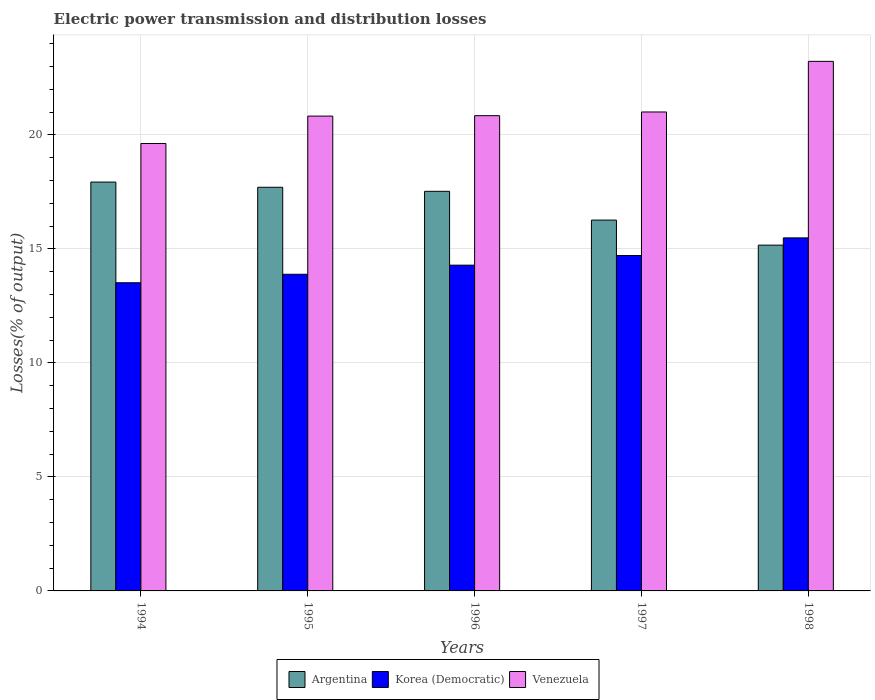How many groups of bars are there?
Keep it short and to the point. 5. Are the number of bars on each tick of the X-axis equal?
Keep it short and to the point. Yes. How many bars are there on the 4th tick from the left?
Keep it short and to the point. 3. What is the label of the 4th group of bars from the left?
Provide a succinct answer. 1997. In how many cases, is the number of bars for a given year not equal to the number of legend labels?
Give a very brief answer. 0. What is the electric power transmission and distribution losses in Korea (Democratic) in 1996?
Keep it short and to the point. 14.29. Across all years, what is the maximum electric power transmission and distribution losses in Venezuela?
Your answer should be compact. 23.22. Across all years, what is the minimum electric power transmission and distribution losses in Venezuela?
Provide a succinct answer. 19.62. In which year was the electric power transmission and distribution losses in Korea (Democratic) minimum?
Offer a very short reply. 1994. What is the total electric power transmission and distribution losses in Venezuela in the graph?
Your answer should be very brief. 105.52. What is the difference between the electric power transmission and distribution losses in Korea (Democratic) in 1994 and that in 1995?
Provide a succinct answer. -0.37. What is the difference between the electric power transmission and distribution losses in Korea (Democratic) in 1998 and the electric power transmission and distribution losses in Argentina in 1995?
Keep it short and to the point. -2.22. What is the average electric power transmission and distribution losses in Venezuela per year?
Your answer should be compact. 21.1. In the year 1994, what is the difference between the electric power transmission and distribution losses in Argentina and electric power transmission and distribution losses in Korea (Democratic)?
Offer a very short reply. 4.42. In how many years, is the electric power transmission and distribution losses in Venezuela greater than 1 %?
Your answer should be very brief. 5. What is the ratio of the electric power transmission and distribution losses in Korea (Democratic) in 1996 to that in 1997?
Your answer should be compact. 0.97. Is the electric power transmission and distribution losses in Korea (Democratic) in 1996 less than that in 1998?
Provide a short and direct response. Yes. What is the difference between the highest and the second highest electric power transmission and distribution losses in Argentina?
Your answer should be very brief. 0.23. What is the difference between the highest and the lowest electric power transmission and distribution losses in Korea (Democratic)?
Ensure brevity in your answer.  1.97. In how many years, is the electric power transmission and distribution losses in Korea (Democratic) greater than the average electric power transmission and distribution losses in Korea (Democratic) taken over all years?
Your response must be concise. 2. What does the 2nd bar from the left in 1994 represents?
Provide a short and direct response. Korea (Democratic). What does the 1st bar from the right in 1994 represents?
Ensure brevity in your answer.  Venezuela. Is it the case that in every year, the sum of the electric power transmission and distribution losses in Argentina and electric power transmission and distribution losses in Venezuela is greater than the electric power transmission and distribution losses in Korea (Democratic)?
Provide a short and direct response. Yes. How many bars are there?
Offer a very short reply. 15. Are all the bars in the graph horizontal?
Provide a short and direct response. No. Are the values on the major ticks of Y-axis written in scientific E-notation?
Your answer should be very brief. No. Where does the legend appear in the graph?
Your response must be concise. Bottom center. How many legend labels are there?
Give a very brief answer. 3. What is the title of the graph?
Offer a terse response. Electric power transmission and distribution losses. Does "Algeria" appear as one of the legend labels in the graph?
Ensure brevity in your answer.  No. What is the label or title of the Y-axis?
Give a very brief answer. Losses(% of output). What is the Losses(% of output) in Argentina in 1994?
Keep it short and to the point. 17.93. What is the Losses(% of output) of Korea (Democratic) in 1994?
Ensure brevity in your answer.  13.52. What is the Losses(% of output) in Venezuela in 1994?
Offer a terse response. 19.62. What is the Losses(% of output) of Argentina in 1995?
Provide a succinct answer. 17.7. What is the Losses(% of output) in Korea (Democratic) in 1995?
Make the answer very short. 13.89. What is the Losses(% of output) of Venezuela in 1995?
Your answer should be compact. 20.82. What is the Losses(% of output) of Argentina in 1996?
Provide a succinct answer. 17.52. What is the Losses(% of output) of Korea (Democratic) in 1996?
Your answer should be compact. 14.29. What is the Losses(% of output) in Venezuela in 1996?
Offer a very short reply. 20.84. What is the Losses(% of output) of Argentina in 1997?
Your response must be concise. 16.26. What is the Losses(% of output) in Korea (Democratic) in 1997?
Your answer should be compact. 14.71. What is the Losses(% of output) of Venezuela in 1997?
Give a very brief answer. 21. What is the Losses(% of output) of Argentina in 1998?
Make the answer very short. 15.16. What is the Losses(% of output) of Korea (Democratic) in 1998?
Your answer should be compact. 15.48. What is the Losses(% of output) in Venezuela in 1998?
Your answer should be very brief. 23.22. Across all years, what is the maximum Losses(% of output) of Argentina?
Make the answer very short. 17.93. Across all years, what is the maximum Losses(% of output) of Korea (Democratic)?
Provide a succinct answer. 15.48. Across all years, what is the maximum Losses(% of output) in Venezuela?
Offer a terse response. 23.22. Across all years, what is the minimum Losses(% of output) in Argentina?
Offer a terse response. 15.16. Across all years, what is the minimum Losses(% of output) in Korea (Democratic)?
Offer a terse response. 13.52. Across all years, what is the minimum Losses(% of output) of Venezuela?
Keep it short and to the point. 19.62. What is the total Losses(% of output) in Argentina in the graph?
Offer a terse response. 84.58. What is the total Losses(% of output) in Korea (Democratic) in the graph?
Provide a short and direct response. 71.88. What is the total Losses(% of output) in Venezuela in the graph?
Your response must be concise. 105.52. What is the difference between the Losses(% of output) in Argentina in 1994 and that in 1995?
Give a very brief answer. 0.23. What is the difference between the Losses(% of output) in Korea (Democratic) in 1994 and that in 1995?
Make the answer very short. -0.37. What is the difference between the Losses(% of output) of Venezuela in 1994 and that in 1995?
Your answer should be compact. -1.2. What is the difference between the Losses(% of output) in Argentina in 1994 and that in 1996?
Your response must be concise. 0.41. What is the difference between the Losses(% of output) in Korea (Democratic) in 1994 and that in 1996?
Your answer should be very brief. -0.77. What is the difference between the Losses(% of output) of Venezuela in 1994 and that in 1996?
Your answer should be compact. -1.22. What is the difference between the Losses(% of output) in Argentina in 1994 and that in 1997?
Your answer should be very brief. 1.67. What is the difference between the Losses(% of output) in Korea (Democratic) in 1994 and that in 1997?
Ensure brevity in your answer.  -1.19. What is the difference between the Losses(% of output) of Venezuela in 1994 and that in 1997?
Provide a succinct answer. -1.38. What is the difference between the Losses(% of output) of Argentina in 1994 and that in 1998?
Provide a succinct answer. 2.77. What is the difference between the Losses(% of output) of Korea (Democratic) in 1994 and that in 1998?
Provide a succinct answer. -1.97. What is the difference between the Losses(% of output) in Venezuela in 1994 and that in 1998?
Keep it short and to the point. -3.6. What is the difference between the Losses(% of output) of Argentina in 1995 and that in 1996?
Keep it short and to the point. 0.18. What is the difference between the Losses(% of output) in Korea (Democratic) in 1995 and that in 1996?
Make the answer very short. -0.4. What is the difference between the Losses(% of output) of Venezuela in 1995 and that in 1996?
Provide a short and direct response. -0.02. What is the difference between the Losses(% of output) in Argentina in 1995 and that in 1997?
Your answer should be compact. 1.44. What is the difference between the Losses(% of output) in Korea (Democratic) in 1995 and that in 1997?
Your answer should be compact. -0.82. What is the difference between the Losses(% of output) in Venezuela in 1995 and that in 1997?
Offer a terse response. -0.18. What is the difference between the Losses(% of output) of Argentina in 1995 and that in 1998?
Provide a succinct answer. 2.54. What is the difference between the Losses(% of output) in Korea (Democratic) in 1995 and that in 1998?
Your answer should be compact. -1.6. What is the difference between the Losses(% of output) in Venezuela in 1995 and that in 1998?
Provide a short and direct response. -2.4. What is the difference between the Losses(% of output) in Argentina in 1996 and that in 1997?
Offer a very short reply. 1.26. What is the difference between the Losses(% of output) of Korea (Democratic) in 1996 and that in 1997?
Keep it short and to the point. -0.42. What is the difference between the Losses(% of output) of Venezuela in 1996 and that in 1997?
Your answer should be very brief. -0.16. What is the difference between the Losses(% of output) of Argentina in 1996 and that in 1998?
Offer a terse response. 2.36. What is the difference between the Losses(% of output) of Korea (Democratic) in 1996 and that in 1998?
Offer a terse response. -1.2. What is the difference between the Losses(% of output) in Venezuela in 1996 and that in 1998?
Ensure brevity in your answer.  -2.38. What is the difference between the Losses(% of output) in Argentina in 1997 and that in 1998?
Make the answer very short. 1.1. What is the difference between the Losses(% of output) in Korea (Democratic) in 1997 and that in 1998?
Make the answer very short. -0.77. What is the difference between the Losses(% of output) in Venezuela in 1997 and that in 1998?
Offer a very short reply. -2.22. What is the difference between the Losses(% of output) of Argentina in 1994 and the Losses(% of output) of Korea (Democratic) in 1995?
Your answer should be very brief. 4.04. What is the difference between the Losses(% of output) of Argentina in 1994 and the Losses(% of output) of Venezuela in 1995?
Ensure brevity in your answer.  -2.89. What is the difference between the Losses(% of output) of Korea (Democratic) in 1994 and the Losses(% of output) of Venezuela in 1995?
Provide a succinct answer. -7.31. What is the difference between the Losses(% of output) of Argentina in 1994 and the Losses(% of output) of Korea (Democratic) in 1996?
Offer a terse response. 3.64. What is the difference between the Losses(% of output) of Argentina in 1994 and the Losses(% of output) of Venezuela in 1996?
Your answer should be compact. -2.91. What is the difference between the Losses(% of output) of Korea (Democratic) in 1994 and the Losses(% of output) of Venezuela in 1996?
Provide a succinct answer. -7.33. What is the difference between the Losses(% of output) of Argentina in 1994 and the Losses(% of output) of Korea (Democratic) in 1997?
Offer a very short reply. 3.22. What is the difference between the Losses(% of output) of Argentina in 1994 and the Losses(% of output) of Venezuela in 1997?
Provide a short and direct response. -3.07. What is the difference between the Losses(% of output) in Korea (Democratic) in 1994 and the Losses(% of output) in Venezuela in 1997?
Provide a short and direct response. -7.49. What is the difference between the Losses(% of output) of Argentina in 1994 and the Losses(% of output) of Korea (Democratic) in 1998?
Make the answer very short. 2.45. What is the difference between the Losses(% of output) in Argentina in 1994 and the Losses(% of output) in Venezuela in 1998?
Offer a very short reply. -5.29. What is the difference between the Losses(% of output) in Korea (Democratic) in 1994 and the Losses(% of output) in Venezuela in 1998?
Provide a succinct answer. -9.71. What is the difference between the Losses(% of output) in Argentina in 1995 and the Losses(% of output) in Korea (Democratic) in 1996?
Provide a succinct answer. 3.42. What is the difference between the Losses(% of output) of Argentina in 1995 and the Losses(% of output) of Venezuela in 1996?
Make the answer very short. -3.14. What is the difference between the Losses(% of output) in Korea (Democratic) in 1995 and the Losses(% of output) in Venezuela in 1996?
Offer a terse response. -6.96. What is the difference between the Losses(% of output) in Argentina in 1995 and the Losses(% of output) in Korea (Democratic) in 1997?
Provide a short and direct response. 2.99. What is the difference between the Losses(% of output) in Argentina in 1995 and the Losses(% of output) in Venezuela in 1997?
Offer a terse response. -3.3. What is the difference between the Losses(% of output) of Korea (Democratic) in 1995 and the Losses(% of output) of Venezuela in 1997?
Ensure brevity in your answer.  -7.12. What is the difference between the Losses(% of output) of Argentina in 1995 and the Losses(% of output) of Korea (Democratic) in 1998?
Ensure brevity in your answer.  2.22. What is the difference between the Losses(% of output) of Argentina in 1995 and the Losses(% of output) of Venezuela in 1998?
Provide a succinct answer. -5.52. What is the difference between the Losses(% of output) of Korea (Democratic) in 1995 and the Losses(% of output) of Venezuela in 1998?
Offer a terse response. -9.34. What is the difference between the Losses(% of output) in Argentina in 1996 and the Losses(% of output) in Korea (Democratic) in 1997?
Provide a succinct answer. 2.81. What is the difference between the Losses(% of output) of Argentina in 1996 and the Losses(% of output) of Venezuela in 1997?
Provide a succinct answer. -3.48. What is the difference between the Losses(% of output) of Korea (Democratic) in 1996 and the Losses(% of output) of Venezuela in 1997?
Provide a short and direct response. -6.72. What is the difference between the Losses(% of output) of Argentina in 1996 and the Losses(% of output) of Korea (Democratic) in 1998?
Make the answer very short. 2.04. What is the difference between the Losses(% of output) of Argentina in 1996 and the Losses(% of output) of Venezuela in 1998?
Your answer should be compact. -5.7. What is the difference between the Losses(% of output) in Korea (Democratic) in 1996 and the Losses(% of output) in Venezuela in 1998?
Your answer should be very brief. -8.94. What is the difference between the Losses(% of output) of Argentina in 1997 and the Losses(% of output) of Korea (Democratic) in 1998?
Make the answer very short. 0.78. What is the difference between the Losses(% of output) of Argentina in 1997 and the Losses(% of output) of Venezuela in 1998?
Give a very brief answer. -6.96. What is the difference between the Losses(% of output) in Korea (Democratic) in 1997 and the Losses(% of output) in Venezuela in 1998?
Your answer should be very brief. -8.51. What is the average Losses(% of output) in Argentina per year?
Keep it short and to the point. 16.92. What is the average Losses(% of output) of Korea (Democratic) per year?
Keep it short and to the point. 14.38. What is the average Losses(% of output) in Venezuela per year?
Your answer should be compact. 21.1. In the year 1994, what is the difference between the Losses(% of output) of Argentina and Losses(% of output) of Korea (Democratic)?
Your response must be concise. 4.42. In the year 1994, what is the difference between the Losses(% of output) in Argentina and Losses(% of output) in Venezuela?
Provide a short and direct response. -1.69. In the year 1994, what is the difference between the Losses(% of output) of Korea (Democratic) and Losses(% of output) of Venezuela?
Keep it short and to the point. -6.11. In the year 1995, what is the difference between the Losses(% of output) of Argentina and Losses(% of output) of Korea (Democratic)?
Your answer should be compact. 3.82. In the year 1995, what is the difference between the Losses(% of output) in Argentina and Losses(% of output) in Venezuela?
Give a very brief answer. -3.12. In the year 1995, what is the difference between the Losses(% of output) in Korea (Democratic) and Losses(% of output) in Venezuela?
Offer a terse response. -6.94. In the year 1996, what is the difference between the Losses(% of output) of Argentina and Losses(% of output) of Korea (Democratic)?
Give a very brief answer. 3.24. In the year 1996, what is the difference between the Losses(% of output) of Argentina and Losses(% of output) of Venezuela?
Offer a terse response. -3.32. In the year 1996, what is the difference between the Losses(% of output) of Korea (Democratic) and Losses(% of output) of Venezuela?
Your response must be concise. -6.56. In the year 1997, what is the difference between the Losses(% of output) in Argentina and Losses(% of output) in Korea (Democratic)?
Make the answer very short. 1.55. In the year 1997, what is the difference between the Losses(% of output) of Argentina and Losses(% of output) of Venezuela?
Keep it short and to the point. -4.74. In the year 1997, what is the difference between the Losses(% of output) in Korea (Democratic) and Losses(% of output) in Venezuela?
Your answer should be compact. -6.29. In the year 1998, what is the difference between the Losses(% of output) in Argentina and Losses(% of output) in Korea (Democratic)?
Provide a short and direct response. -0.32. In the year 1998, what is the difference between the Losses(% of output) in Argentina and Losses(% of output) in Venezuela?
Keep it short and to the point. -8.06. In the year 1998, what is the difference between the Losses(% of output) in Korea (Democratic) and Losses(% of output) in Venezuela?
Make the answer very short. -7.74. What is the ratio of the Losses(% of output) of Argentina in 1994 to that in 1995?
Offer a terse response. 1.01. What is the ratio of the Losses(% of output) of Korea (Democratic) in 1994 to that in 1995?
Provide a succinct answer. 0.97. What is the ratio of the Losses(% of output) in Venezuela in 1994 to that in 1995?
Offer a very short reply. 0.94. What is the ratio of the Losses(% of output) in Argentina in 1994 to that in 1996?
Your response must be concise. 1.02. What is the ratio of the Losses(% of output) in Korea (Democratic) in 1994 to that in 1996?
Offer a very short reply. 0.95. What is the ratio of the Losses(% of output) of Venezuela in 1994 to that in 1996?
Your response must be concise. 0.94. What is the ratio of the Losses(% of output) in Argentina in 1994 to that in 1997?
Offer a terse response. 1.1. What is the ratio of the Losses(% of output) of Korea (Democratic) in 1994 to that in 1997?
Provide a short and direct response. 0.92. What is the ratio of the Losses(% of output) of Venezuela in 1994 to that in 1997?
Your answer should be very brief. 0.93. What is the ratio of the Losses(% of output) in Argentina in 1994 to that in 1998?
Offer a terse response. 1.18. What is the ratio of the Losses(% of output) of Korea (Democratic) in 1994 to that in 1998?
Your answer should be very brief. 0.87. What is the ratio of the Losses(% of output) of Venezuela in 1994 to that in 1998?
Offer a very short reply. 0.84. What is the ratio of the Losses(% of output) in Argentina in 1995 to that in 1996?
Give a very brief answer. 1.01. What is the ratio of the Losses(% of output) in Venezuela in 1995 to that in 1996?
Offer a very short reply. 1. What is the ratio of the Losses(% of output) of Argentina in 1995 to that in 1997?
Your answer should be compact. 1.09. What is the ratio of the Losses(% of output) in Korea (Democratic) in 1995 to that in 1997?
Provide a short and direct response. 0.94. What is the ratio of the Losses(% of output) of Argentina in 1995 to that in 1998?
Give a very brief answer. 1.17. What is the ratio of the Losses(% of output) of Korea (Democratic) in 1995 to that in 1998?
Offer a very short reply. 0.9. What is the ratio of the Losses(% of output) in Venezuela in 1995 to that in 1998?
Offer a very short reply. 0.9. What is the ratio of the Losses(% of output) of Argentina in 1996 to that in 1997?
Your answer should be very brief. 1.08. What is the ratio of the Losses(% of output) of Korea (Democratic) in 1996 to that in 1997?
Ensure brevity in your answer.  0.97. What is the ratio of the Losses(% of output) in Venezuela in 1996 to that in 1997?
Provide a succinct answer. 0.99. What is the ratio of the Losses(% of output) in Argentina in 1996 to that in 1998?
Provide a short and direct response. 1.16. What is the ratio of the Losses(% of output) in Korea (Democratic) in 1996 to that in 1998?
Your answer should be very brief. 0.92. What is the ratio of the Losses(% of output) of Venezuela in 1996 to that in 1998?
Make the answer very short. 0.9. What is the ratio of the Losses(% of output) of Argentina in 1997 to that in 1998?
Provide a succinct answer. 1.07. What is the ratio of the Losses(% of output) of Korea (Democratic) in 1997 to that in 1998?
Your answer should be compact. 0.95. What is the ratio of the Losses(% of output) of Venezuela in 1997 to that in 1998?
Make the answer very short. 0.9. What is the difference between the highest and the second highest Losses(% of output) of Argentina?
Give a very brief answer. 0.23. What is the difference between the highest and the second highest Losses(% of output) in Korea (Democratic)?
Your response must be concise. 0.77. What is the difference between the highest and the second highest Losses(% of output) of Venezuela?
Make the answer very short. 2.22. What is the difference between the highest and the lowest Losses(% of output) in Argentina?
Your answer should be compact. 2.77. What is the difference between the highest and the lowest Losses(% of output) of Korea (Democratic)?
Make the answer very short. 1.97. What is the difference between the highest and the lowest Losses(% of output) of Venezuela?
Keep it short and to the point. 3.6. 